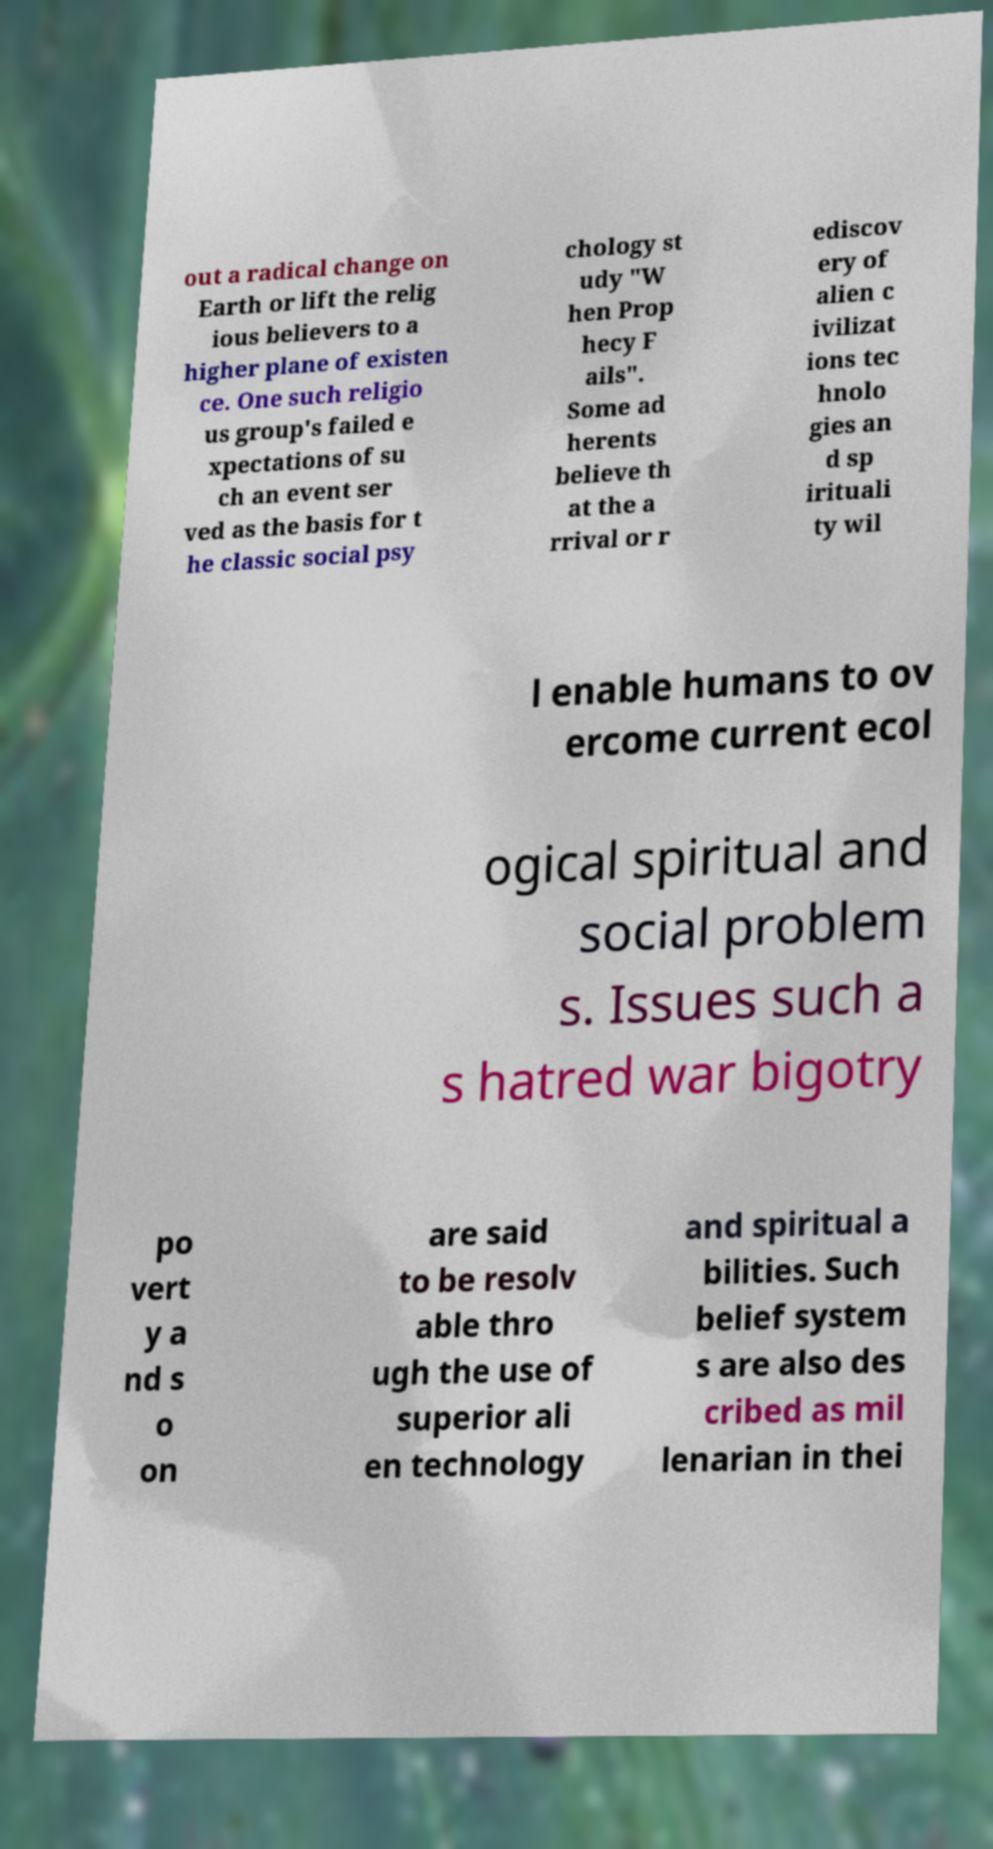Can you accurately transcribe the text from the provided image for me? out a radical change on Earth or lift the relig ious believers to a higher plane of existen ce. One such religio us group's failed e xpectations of su ch an event ser ved as the basis for t he classic social psy chology st udy "W hen Prop hecy F ails". Some ad herents believe th at the a rrival or r ediscov ery of alien c ivilizat ions tec hnolo gies an d sp irituali ty wil l enable humans to ov ercome current ecol ogical spiritual and social problem s. Issues such a s hatred war bigotry po vert y a nd s o on are said to be resolv able thro ugh the use of superior ali en technology and spiritual a bilities. Such belief system s are also des cribed as mil lenarian in thei 